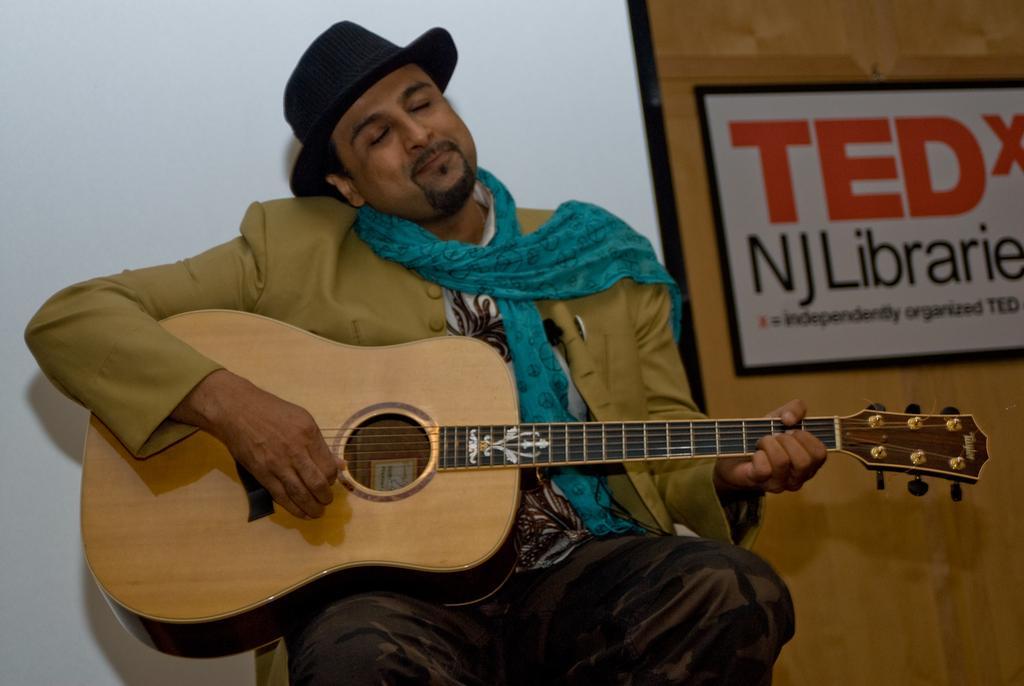In one or two sentences, can you explain what this image depicts? This person sitting and holding guitar and wear cap. On the background we can see wall and poster. 